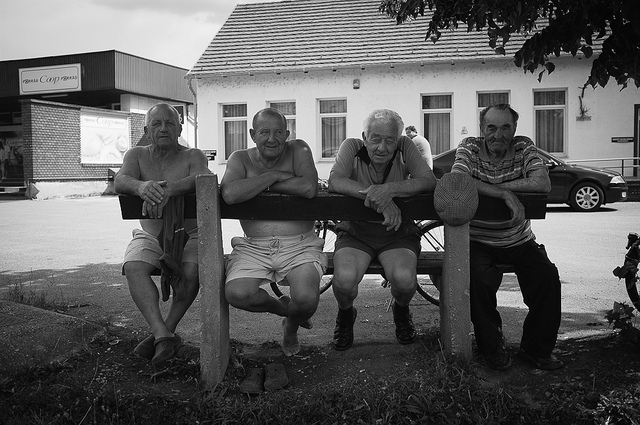<image>What does the family keep as a pet? It is uncertain what pet the family keeps. It could be a dog, a fish, a cat or nothing. What does the family keep as a pet? The family keeps a pet, but it is unclear what kind of pet it is. It can be a dog, a cat or fish. 